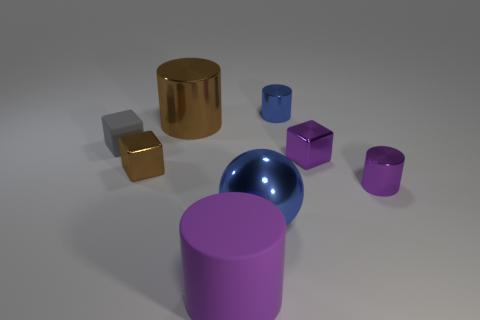Add 2 cyan spheres. How many objects exist? 10 Subtract all spheres. How many objects are left? 7 Subtract 0 brown balls. How many objects are left? 8 Subtract all shiny cylinders. Subtract all big spheres. How many objects are left? 4 Add 4 big purple rubber cylinders. How many big purple rubber cylinders are left? 5 Add 8 brown metallic cylinders. How many brown metallic cylinders exist? 9 